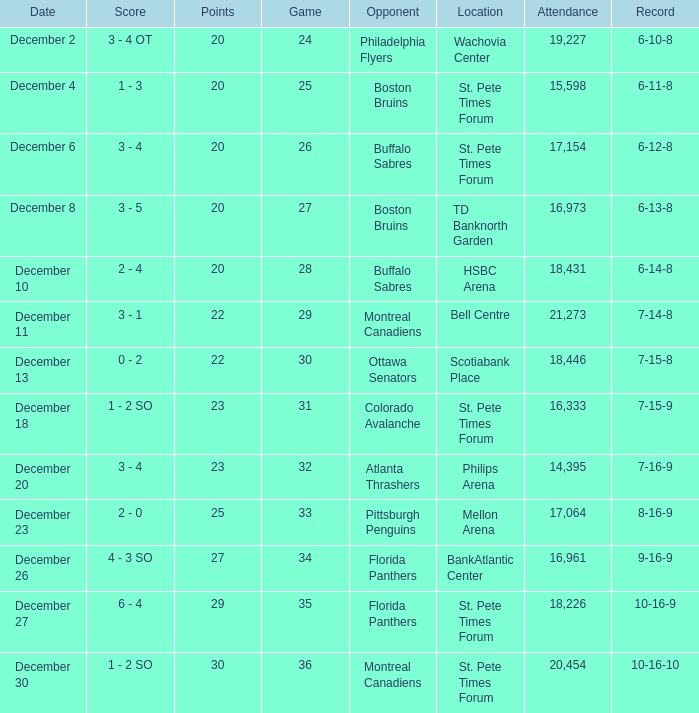What game has a 6-12-8 record? 26.0. 